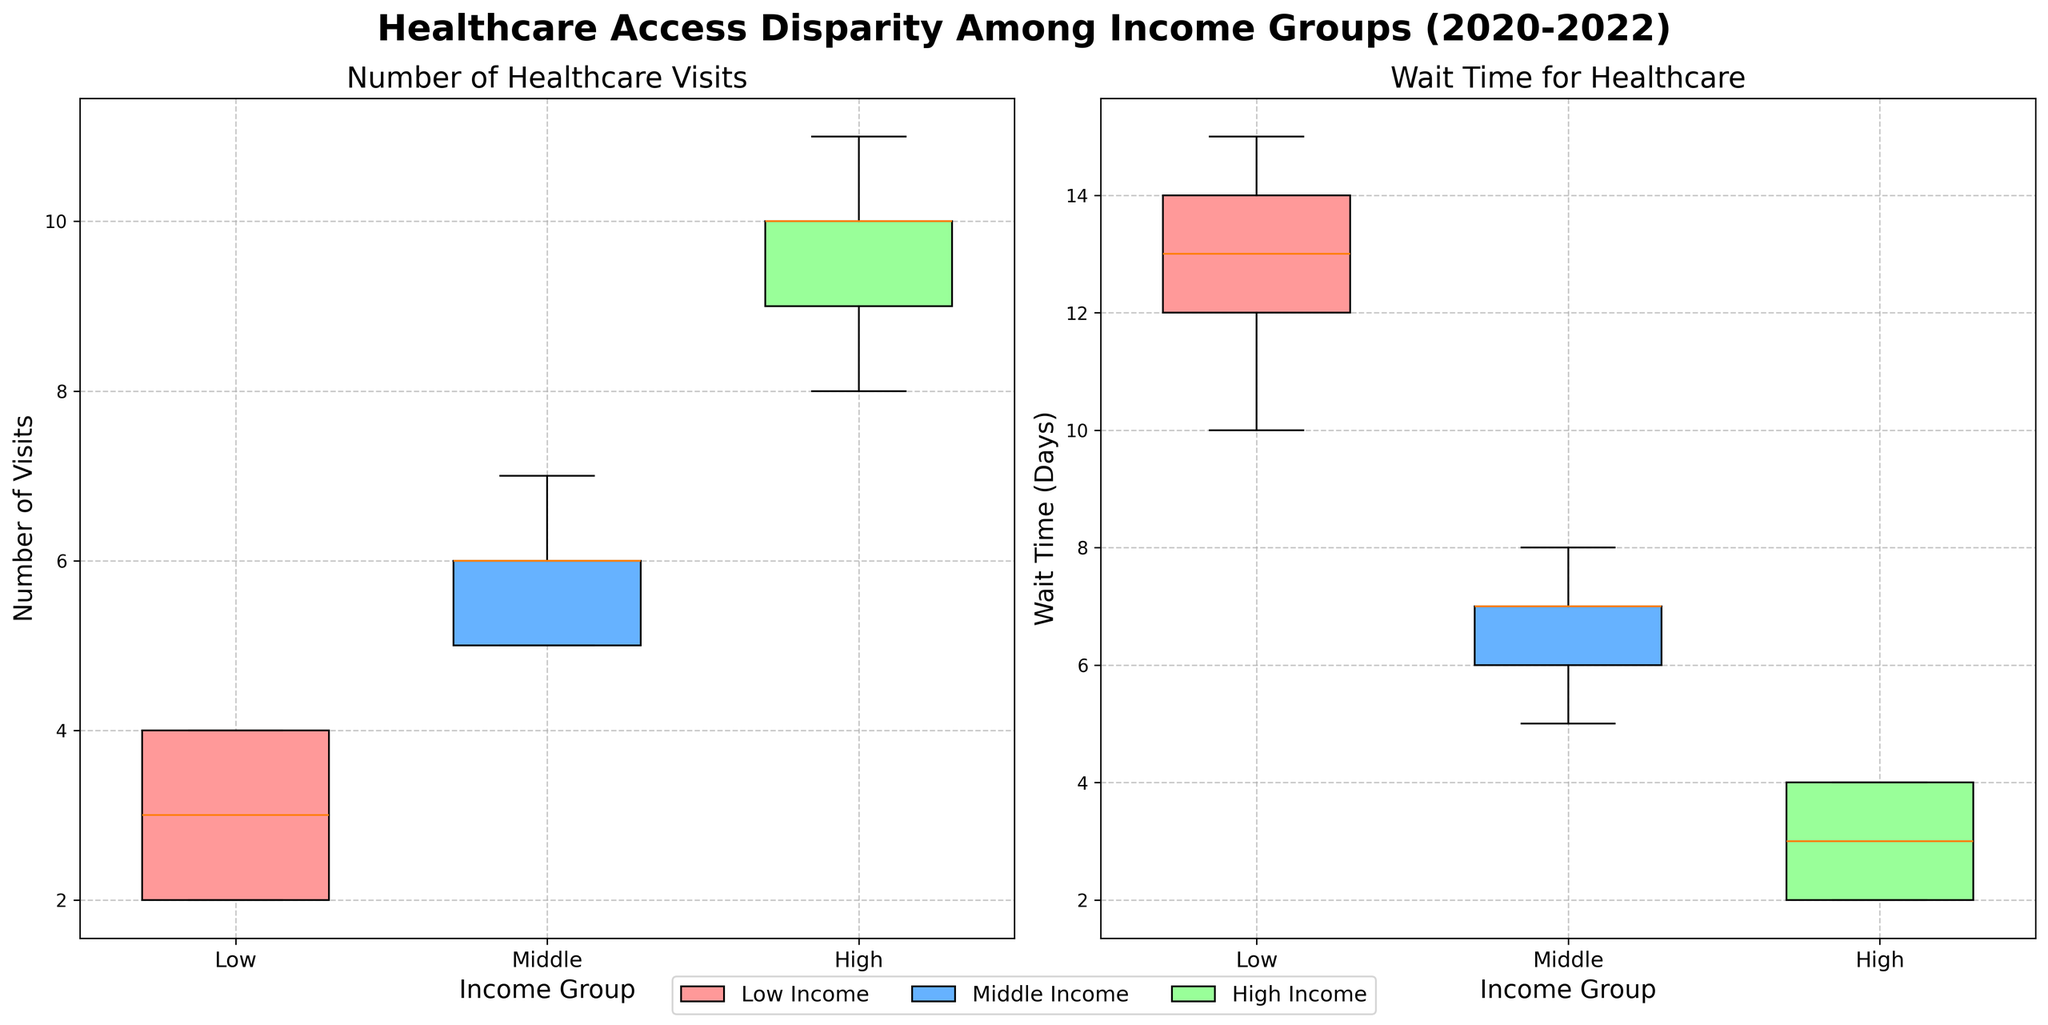What is the title of the figure? The title is displayed at the top of the figure in a bold and larger font size, indicating what the figure is about. The title reads "Healthcare Access Disparity Among Income Groups (2020-2022)."
Answer: Healthcare Access Disparity Among Income Groups (2020-2022) Which income group had the highest median number of healthcare visits? By examining the middle line (the median) of each box plot in the "Number of Healthcare Visits" subplot, it is clear that the High Income group's box plot has the highest median line.
Answer: High Income What is the range of wait times for the Low Income group? The range can be identified by looking at the "Wait Time for Healthcare" subplot and finding the minimum and maximum values within the box plot for the Low Income group. The minimum wait time is around 10 days, and the maximum wait time is around 15 days, giving a range of 15 - 10 = 5 days.
Answer: 5 days Which income group has the shortest wait times for healthcare? By observing the "Wait Time for Healthcare" subplot, we can see that the High Income group has the lowest median and overall shorter waiting times compared to the other groups.
Answer: High Income How do the number of healthcare visits compare between Low Income and Middle Income groups? Reviewing the "Number of Healthcare Visits" subplot, we can see that the Middle Income group tends to have higher numbers of healthcare visits compared to the Low Income group, as indicated by higher positions of the median and quartiles.
Answer: Middle Income has more visits What can be inferred about the connection between income and wait time for healthcare? Analyzing the "Wait Time for Healthcare" subplot, it is evident that higher income groups have shorter wait times. This suggests that there may be a correlation where higher income leads to better access and shorter wait times for healthcare.
Answer: Higher income, shorter wait time What is the interquartile range (IQR) of healthcare visits for the Middle Income group? The IQR is calculated as the difference between the third quartile (Q3) and the first quartile (Q1). From the "Number of Healthcare Visits" subplot, visually estimate these quartiles for the Middle Income group; it appears they are around 7 and 5, respectively. Therefore, the IQR is 7 - 5 = 2.
Answer: 2 Which income group shows the most variability in healthcare visit numbers? Variability within a box plot is often indicated by the length of the box and the spread of the whiskers. Observing the "Number of Healthcare Visits" subplot, the High Income group has the longest box and whiskers, suggesting the greatest variability.
Answer: High Income 